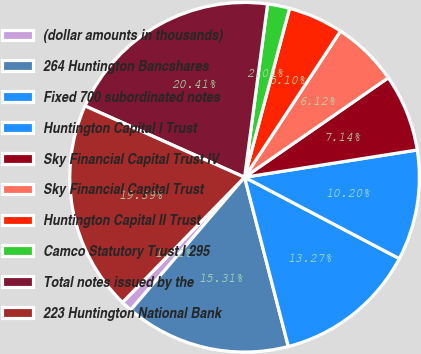<chart> <loc_0><loc_0><loc_500><loc_500><pie_chart><fcel>(dollar amounts in thousands)<fcel>264 Huntington Bancshares<fcel>Fixed 700 subordinated notes<fcel>Huntington Capital I Trust<fcel>Sky Financial Capital Trust IV<fcel>Sky Financial Capital Trust<fcel>Huntington Capital II Trust<fcel>Camco Statutory Trust I 295<fcel>Total notes issued by the<fcel>223 Huntington National Bank<nl><fcel>1.02%<fcel>15.31%<fcel>13.27%<fcel>10.2%<fcel>7.14%<fcel>6.12%<fcel>5.1%<fcel>2.04%<fcel>20.41%<fcel>19.39%<nl></chart> 